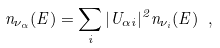Convert formula to latex. <formula><loc_0><loc_0><loc_500><loc_500>n _ { \nu _ { \alpha } } ( E ) = \sum _ { i } | U _ { \alpha i } | ^ { 2 } n _ { \nu _ { i } } ( E ) \ ,</formula> 